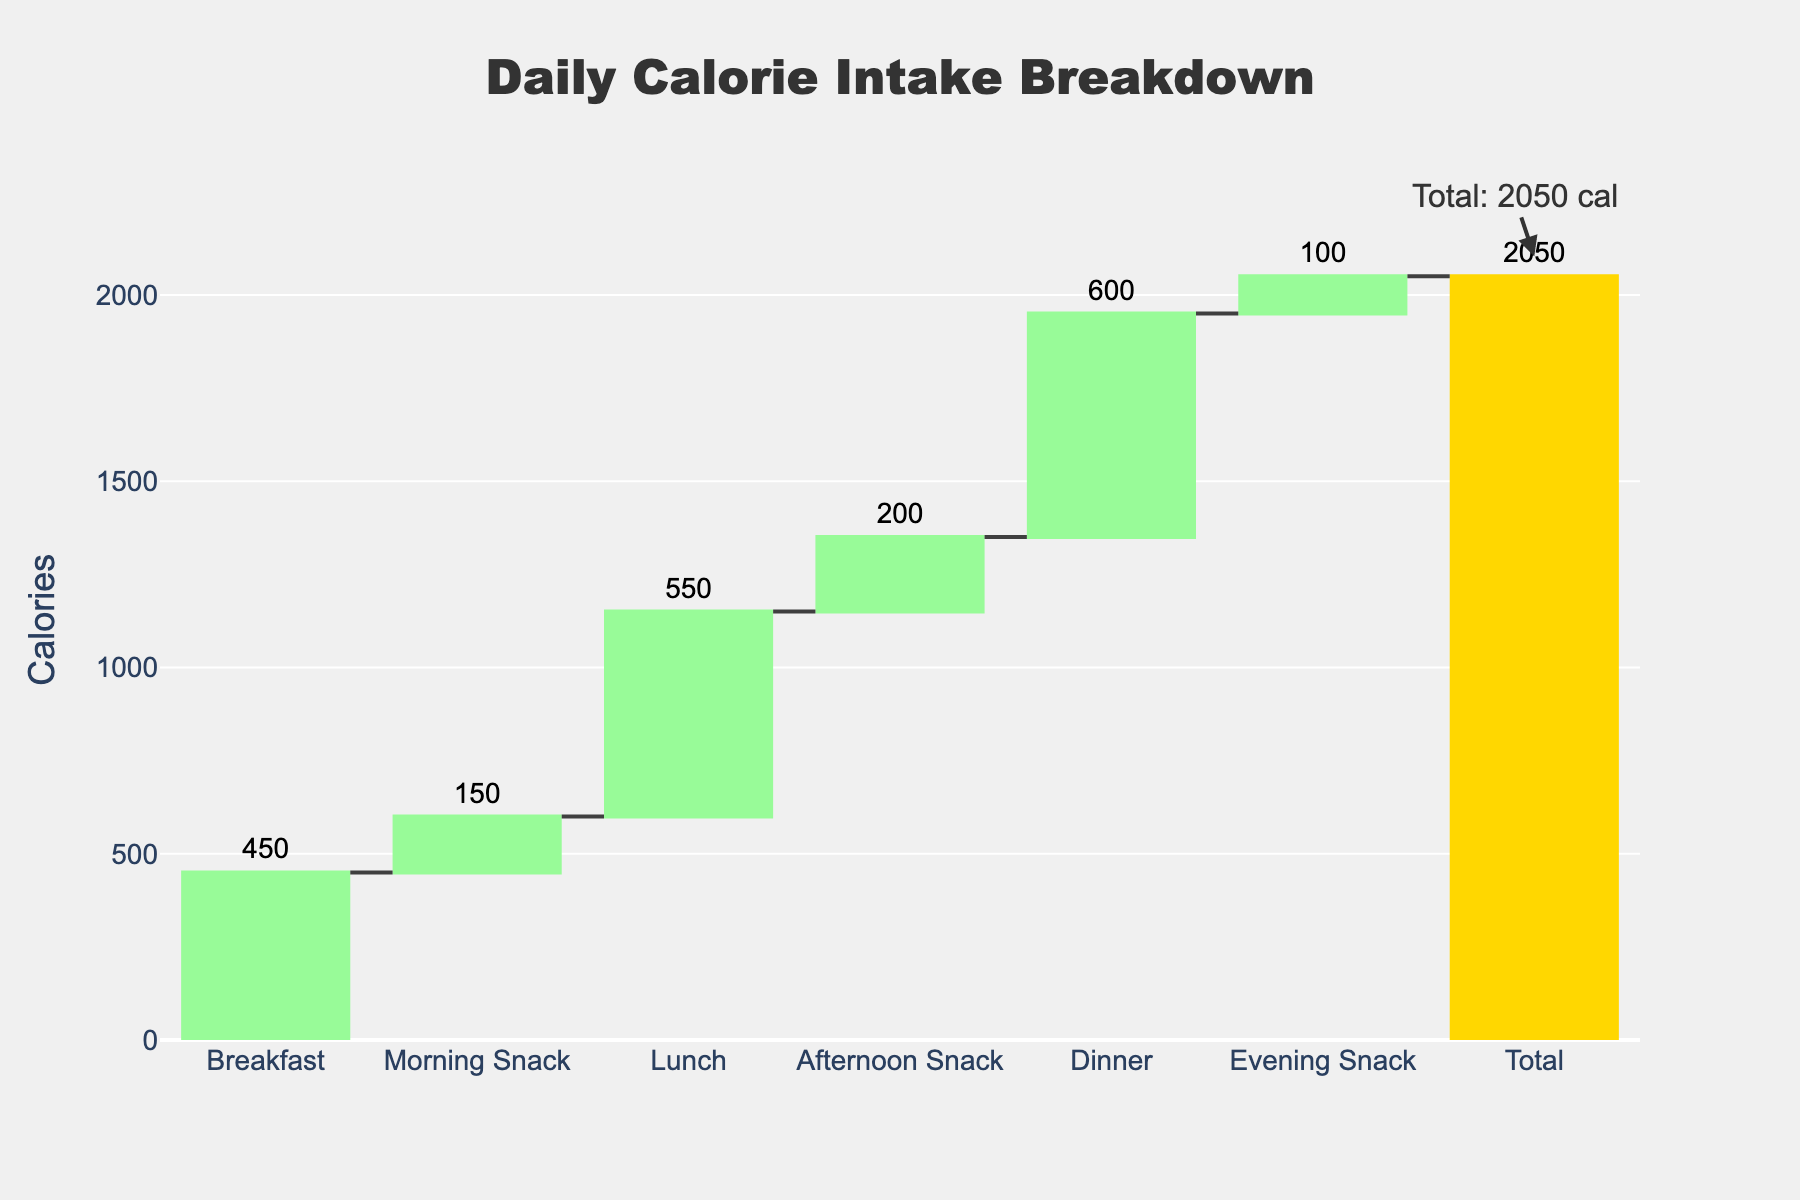How many categories are displayed in the figure? The waterfall chart shows six categories for meals and snacks plus one 'Total' category.
Answer: 7 What is the highest-calorie meal displayed? By looking at the height of the bars, Dinner has the highest caloric intake at 600 calories.
Answer: Dinner What is the total daily calorie intake? The 'Total' bar at the end of the waterfall chart provides the summary of all the previous categories, which is labeled 2050 calories.
Answer: 2050 How many calories come from snacks throughout the day? Adding the calories from Morning Snack, Afternoon Snack, and Evening Snack: 150 + 200 + 100 = 450 calories.
Answer: 450 Which meal contributes fewer calories: Breakfast or Lunch? Comparing the bars, Breakfast has 450 calories, while Lunch has 550 calories, meaning Breakfast contributes fewer calories.
Answer: Breakfast What is the difference in calorie intake between Lunch and Dinner? Subtracting the calories of Lunch from Dinner: 600 - 550 = 50 calories.
Answer: 50 How do the total calories from snacks compare to the calories from Dinner? Calories from snacks total 450, and Dinner provides 600 calories. 450 is less than 600.
Answer: Snacks provide fewer calories than Dinner Is the Evening Snack calorie intake more than the Morning Snack calorie intake? Comparing the bars for Evening Snack and Morning Snack, Evening Snack has 100 calories and Morning Snack has 150. 100 is less than 150.
Answer: No What is the combined caloric intake of Breakfast and Afternoon Snack? Sum of Breakfast (450) and Afternoon Snack (200): 450 + 200 = 650 calories.
Answer: 650 How does the caloric contribution of Morning Snack compare to Evening Snack? Comparing the bars, Morning Snack has 150 calories, while Evening Snack has 100 calories. 150 is greater than 100.
Answer: Morning Snack has more calories 